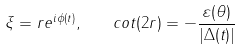Convert formula to latex. <formula><loc_0><loc_0><loc_500><loc_500>\xi = r e ^ { i \phi ( t ) } , \quad c o t ( 2 r ) = - \frac { \varepsilon ( \theta ) } { | \Delta ( t ) | }</formula> 